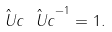<formula> <loc_0><loc_0><loc_500><loc_500>\hat { \ U c } \hat { \ U c } ^ { - 1 } = 1 .</formula> 